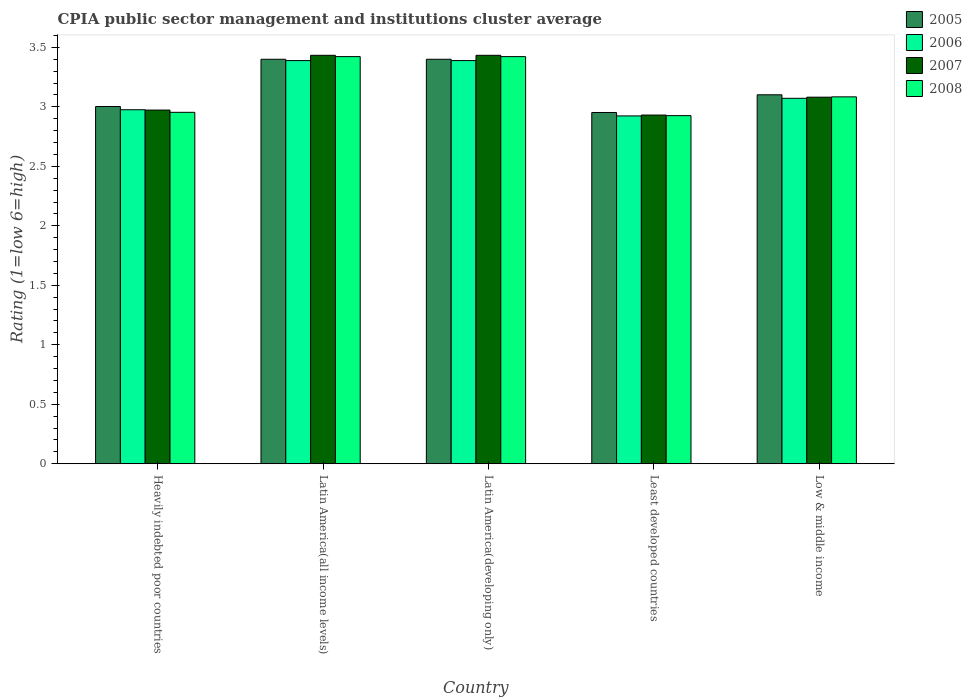How many different coloured bars are there?
Your answer should be compact. 4. How many bars are there on the 1st tick from the left?
Make the answer very short. 4. How many bars are there on the 2nd tick from the right?
Ensure brevity in your answer.  4. What is the label of the 1st group of bars from the left?
Provide a short and direct response. Heavily indebted poor countries. What is the CPIA rating in 2008 in Low & middle income?
Offer a terse response. 3.08. Across all countries, what is the maximum CPIA rating in 2007?
Offer a terse response. 3.43. Across all countries, what is the minimum CPIA rating in 2006?
Your response must be concise. 2.92. In which country was the CPIA rating in 2006 maximum?
Your answer should be very brief. Latin America(all income levels). In which country was the CPIA rating in 2008 minimum?
Make the answer very short. Least developed countries. What is the total CPIA rating in 2008 in the graph?
Keep it short and to the point. 15.81. What is the difference between the CPIA rating in 2006 in Heavily indebted poor countries and that in Least developed countries?
Offer a terse response. 0.05. What is the difference between the CPIA rating in 2005 in Heavily indebted poor countries and the CPIA rating in 2007 in Least developed countries?
Make the answer very short. 0.07. What is the average CPIA rating in 2007 per country?
Your answer should be very brief. 3.17. What is the difference between the CPIA rating of/in 2007 and CPIA rating of/in 2006 in Latin America(all income levels)?
Provide a succinct answer. 0.04. In how many countries, is the CPIA rating in 2005 greater than 0.2?
Offer a very short reply. 5. What is the ratio of the CPIA rating in 2008 in Latin America(all income levels) to that in Least developed countries?
Your answer should be compact. 1.17. Is the CPIA rating in 2005 in Latin America(developing only) less than that in Low & middle income?
Your answer should be very brief. No. Is the difference between the CPIA rating in 2007 in Latin America(developing only) and Low & middle income greater than the difference between the CPIA rating in 2006 in Latin America(developing only) and Low & middle income?
Keep it short and to the point. Yes. What is the difference between the highest and the second highest CPIA rating in 2005?
Give a very brief answer. -0.3. What is the difference between the highest and the lowest CPIA rating in 2007?
Ensure brevity in your answer.  0.5. In how many countries, is the CPIA rating in 2006 greater than the average CPIA rating in 2006 taken over all countries?
Your answer should be very brief. 2. How many bars are there?
Your response must be concise. 20. Where does the legend appear in the graph?
Offer a very short reply. Top right. How many legend labels are there?
Keep it short and to the point. 4. What is the title of the graph?
Your answer should be compact. CPIA public sector management and institutions cluster average. What is the label or title of the X-axis?
Ensure brevity in your answer.  Country. What is the Rating (1=low 6=high) in 2005 in Heavily indebted poor countries?
Make the answer very short. 3. What is the Rating (1=low 6=high) in 2006 in Heavily indebted poor countries?
Your answer should be very brief. 2.98. What is the Rating (1=low 6=high) in 2007 in Heavily indebted poor countries?
Your answer should be very brief. 2.97. What is the Rating (1=low 6=high) in 2008 in Heavily indebted poor countries?
Keep it short and to the point. 2.95. What is the Rating (1=low 6=high) in 2006 in Latin America(all income levels)?
Offer a terse response. 3.39. What is the Rating (1=low 6=high) in 2007 in Latin America(all income levels)?
Keep it short and to the point. 3.43. What is the Rating (1=low 6=high) of 2008 in Latin America(all income levels)?
Your answer should be very brief. 3.42. What is the Rating (1=low 6=high) in 2006 in Latin America(developing only)?
Provide a short and direct response. 3.39. What is the Rating (1=low 6=high) of 2007 in Latin America(developing only)?
Make the answer very short. 3.43. What is the Rating (1=low 6=high) in 2008 in Latin America(developing only)?
Give a very brief answer. 3.42. What is the Rating (1=low 6=high) of 2005 in Least developed countries?
Make the answer very short. 2.95. What is the Rating (1=low 6=high) in 2006 in Least developed countries?
Make the answer very short. 2.92. What is the Rating (1=low 6=high) in 2007 in Least developed countries?
Provide a short and direct response. 2.93. What is the Rating (1=low 6=high) in 2008 in Least developed countries?
Make the answer very short. 2.93. What is the Rating (1=low 6=high) of 2005 in Low & middle income?
Make the answer very short. 3.1. What is the Rating (1=low 6=high) in 2006 in Low & middle income?
Your response must be concise. 3.07. What is the Rating (1=low 6=high) of 2007 in Low & middle income?
Provide a short and direct response. 3.08. What is the Rating (1=low 6=high) in 2008 in Low & middle income?
Make the answer very short. 3.08. Across all countries, what is the maximum Rating (1=low 6=high) in 2005?
Your response must be concise. 3.4. Across all countries, what is the maximum Rating (1=low 6=high) in 2006?
Offer a terse response. 3.39. Across all countries, what is the maximum Rating (1=low 6=high) in 2007?
Make the answer very short. 3.43. Across all countries, what is the maximum Rating (1=low 6=high) in 2008?
Your answer should be very brief. 3.42. Across all countries, what is the minimum Rating (1=low 6=high) in 2005?
Your answer should be compact. 2.95. Across all countries, what is the minimum Rating (1=low 6=high) of 2006?
Ensure brevity in your answer.  2.92. Across all countries, what is the minimum Rating (1=low 6=high) in 2007?
Provide a succinct answer. 2.93. Across all countries, what is the minimum Rating (1=low 6=high) of 2008?
Provide a succinct answer. 2.93. What is the total Rating (1=low 6=high) of 2005 in the graph?
Offer a terse response. 15.86. What is the total Rating (1=low 6=high) in 2006 in the graph?
Ensure brevity in your answer.  15.75. What is the total Rating (1=low 6=high) of 2007 in the graph?
Ensure brevity in your answer.  15.85. What is the total Rating (1=low 6=high) in 2008 in the graph?
Make the answer very short. 15.81. What is the difference between the Rating (1=low 6=high) of 2005 in Heavily indebted poor countries and that in Latin America(all income levels)?
Make the answer very short. -0.4. What is the difference between the Rating (1=low 6=high) of 2006 in Heavily indebted poor countries and that in Latin America(all income levels)?
Provide a succinct answer. -0.41. What is the difference between the Rating (1=low 6=high) of 2007 in Heavily indebted poor countries and that in Latin America(all income levels)?
Your answer should be compact. -0.46. What is the difference between the Rating (1=low 6=high) of 2008 in Heavily indebted poor countries and that in Latin America(all income levels)?
Your answer should be very brief. -0.47. What is the difference between the Rating (1=low 6=high) of 2005 in Heavily indebted poor countries and that in Latin America(developing only)?
Your response must be concise. -0.4. What is the difference between the Rating (1=low 6=high) in 2006 in Heavily indebted poor countries and that in Latin America(developing only)?
Your answer should be very brief. -0.41. What is the difference between the Rating (1=low 6=high) of 2007 in Heavily indebted poor countries and that in Latin America(developing only)?
Offer a terse response. -0.46. What is the difference between the Rating (1=low 6=high) in 2008 in Heavily indebted poor countries and that in Latin America(developing only)?
Your answer should be very brief. -0.47. What is the difference between the Rating (1=low 6=high) of 2005 in Heavily indebted poor countries and that in Least developed countries?
Provide a short and direct response. 0.05. What is the difference between the Rating (1=low 6=high) of 2006 in Heavily indebted poor countries and that in Least developed countries?
Provide a short and direct response. 0.05. What is the difference between the Rating (1=low 6=high) of 2007 in Heavily indebted poor countries and that in Least developed countries?
Provide a succinct answer. 0.04. What is the difference between the Rating (1=low 6=high) in 2008 in Heavily indebted poor countries and that in Least developed countries?
Offer a very short reply. 0.03. What is the difference between the Rating (1=low 6=high) of 2005 in Heavily indebted poor countries and that in Low & middle income?
Ensure brevity in your answer.  -0.1. What is the difference between the Rating (1=low 6=high) in 2006 in Heavily indebted poor countries and that in Low & middle income?
Your answer should be very brief. -0.1. What is the difference between the Rating (1=low 6=high) of 2007 in Heavily indebted poor countries and that in Low & middle income?
Offer a terse response. -0.11. What is the difference between the Rating (1=low 6=high) in 2008 in Heavily indebted poor countries and that in Low & middle income?
Offer a terse response. -0.13. What is the difference between the Rating (1=low 6=high) of 2005 in Latin America(all income levels) and that in Latin America(developing only)?
Your answer should be very brief. 0. What is the difference between the Rating (1=low 6=high) in 2008 in Latin America(all income levels) and that in Latin America(developing only)?
Ensure brevity in your answer.  0. What is the difference between the Rating (1=low 6=high) of 2005 in Latin America(all income levels) and that in Least developed countries?
Your answer should be very brief. 0.45. What is the difference between the Rating (1=low 6=high) in 2006 in Latin America(all income levels) and that in Least developed countries?
Your answer should be very brief. 0.47. What is the difference between the Rating (1=low 6=high) in 2007 in Latin America(all income levels) and that in Least developed countries?
Your answer should be very brief. 0.5. What is the difference between the Rating (1=low 6=high) in 2008 in Latin America(all income levels) and that in Least developed countries?
Your answer should be compact. 0.5. What is the difference between the Rating (1=low 6=high) of 2005 in Latin America(all income levels) and that in Low & middle income?
Provide a short and direct response. 0.3. What is the difference between the Rating (1=low 6=high) of 2006 in Latin America(all income levels) and that in Low & middle income?
Offer a terse response. 0.32. What is the difference between the Rating (1=low 6=high) in 2007 in Latin America(all income levels) and that in Low & middle income?
Provide a short and direct response. 0.35. What is the difference between the Rating (1=low 6=high) in 2008 in Latin America(all income levels) and that in Low & middle income?
Provide a short and direct response. 0.34. What is the difference between the Rating (1=low 6=high) of 2005 in Latin America(developing only) and that in Least developed countries?
Provide a succinct answer. 0.45. What is the difference between the Rating (1=low 6=high) in 2006 in Latin America(developing only) and that in Least developed countries?
Make the answer very short. 0.47. What is the difference between the Rating (1=low 6=high) of 2007 in Latin America(developing only) and that in Least developed countries?
Make the answer very short. 0.5. What is the difference between the Rating (1=low 6=high) of 2008 in Latin America(developing only) and that in Least developed countries?
Ensure brevity in your answer.  0.5. What is the difference between the Rating (1=low 6=high) in 2005 in Latin America(developing only) and that in Low & middle income?
Give a very brief answer. 0.3. What is the difference between the Rating (1=low 6=high) in 2006 in Latin America(developing only) and that in Low & middle income?
Offer a terse response. 0.32. What is the difference between the Rating (1=low 6=high) of 2007 in Latin America(developing only) and that in Low & middle income?
Your answer should be very brief. 0.35. What is the difference between the Rating (1=low 6=high) in 2008 in Latin America(developing only) and that in Low & middle income?
Offer a terse response. 0.34. What is the difference between the Rating (1=low 6=high) in 2005 in Least developed countries and that in Low & middle income?
Your answer should be very brief. -0.15. What is the difference between the Rating (1=low 6=high) in 2006 in Least developed countries and that in Low & middle income?
Your answer should be compact. -0.15. What is the difference between the Rating (1=low 6=high) of 2007 in Least developed countries and that in Low & middle income?
Give a very brief answer. -0.15. What is the difference between the Rating (1=low 6=high) of 2008 in Least developed countries and that in Low & middle income?
Give a very brief answer. -0.16. What is the difference between the Rating (1=low 6=high) of 2005 in Heavily indebted poor countries and the Rating (1=low 6=high) of 2006 in Latin America(all income levels)?
Your response must be concise. -0.39. What is the difference between the Rating (1=low 6=high) in 2005 in Heavily indebted poor countries and the Rating (1=low 6=high) in 2007 in Latin America(all income levels)?
Make the answer very short. -0.43. What is the difference between the Rating (1=low 6=high) in 2005 in Heavily indebted poor countries and the Rating (1=low 6=high) in 2008 in Latin America(all income levels)?
Your response must be concise. -0.42. What is the difference between the Rating (1=low 6=high) in 2006 in Heavily indebted poor countries and the Rating (1=low 6=high) in 2007 in Latin America(all income levels)?
Your answer should be compact. -0.46. What is the difference between the Rating (1=low 6=high) of 2006 in Heavily indebted poor countries and the Rating (1=low 6=high) of 2008 in Latin America(all income levels)?
Provide a short and direct response. -0.45. What is the difference between the Rating (1=low 6=high) of 2007 in Heavily indebted poor countries and the Rating (1=low 6=high) of 2008 in Latin America(all income levels)?
Offer a very short reply. -0.45. What is the difference between the Rating (1=low 6=high) in 2005 in Heavily indebted poor countries and the Rating (1=low 6=high) in 2006 in Latin America(developing only)?
Offer a terse response. -0.39. What is the difference between the Rating (1=low 6=high) in 2005 in Heavily indebted poor countries and the Rating (1=low 6=high) in 2007 in Latin America(developing only)?
Your answer should be compact. -0.43. What is the difference between the Rating (1=low 6=high) of 2005 in Heavily indebted poor countries and the Rating (1=low 6=high) of 2008 in Latin America(developing only)?
Provide a short and direct response. -0.42. What is the difference between the Rating (1=low 6=high) of 2006 in Heavily indebted poor countries and the Rating (1=low 6=high) of 2007 in Latin America(developing only)?
Provide a succinct answer. -0.46. What is the difference between the Rating (1=low 6=high) in 2006 in Heavily indebted poor countries and the Rating (1=low 6=high) in 2008 in Latin America(developing only)?
Keep it short and to the point. -0.45. What is the difference between the Rating (1=low 6=high) of 2007 in Heavily indebted poor countries and the Rating (1=low 6=high) of 2008 in Latin America(developing only)?
Make the answer very short. -0.45. What is the difference between the Rating (1=low 6=high) in 2005 in Heavily indebted poor countries and the Rating (1=low 6=high) in 2006 in Least developed countries?
Keep it short and to the point. 0.08. What is the difference between the Rating (1=low 6=high) of 2005 in Heavily indebted poor countries and the Rating (1=low 6=high) of 2007 in Least developed countries?
Offer a very short reply. 0.07. What is the difference between the Rating (1=low 6=high) of 2005 in Heavily indebted poor countries and the Rating (1=low 6=high) of 2008 in Least developed countries?
Your answer should be very brief. 0.08. What is the difference between the Rating (1=low 6=high) in 2006 in Heavily indebted poor countries and the Rating (1=low 6=high) in 2007 in Least developed countries?
Give a very brief answer. 0.04. What is the difference between the Rating (1=low 6=high) in 2006 in Heavily indebted poor countries and the Rating (1=low 6=high) in 2008 in Least developed countries?
Offer a terse response. 0.05. What is the difference between the Rating (1=low 6=high) in 2007 in Heavily indebted poor countries and the Rating (1=low 6=high) in 2008 in Least developed countries?
Offer a very short reply. 0.05. What is the difference between the Rating (1=low 6=high) in 2005 in Heavily indebted poor countries and the Rating (1=low 6=high) in 2006 in Low & middle income?
Ensure brevity in your answer.  -0.07. What is the difference between the Rating (1=low 6=high) of 2005 in Heavily indebted poor countries and the Rating (1=low 6=high) of 2007 in Low & middle income?
Ensure brevity in your answer.  -0.08. What is the difference between the Rating (1=low 6=high) in 2005 in Heavily indebted poor countries and the Rating (1=low 6=high) in 2008 in Low & middle income?
Your answer should be compact. -0.08. What is the difference between the Rating (1=low 6=high) in 2006 in Heavily indebted poor countries and the Rating (1=low 6=high) in 2007 in Low & middle income?
Your answer should be very brief. -0.11. What is the difference between the Rating (1=low 6=high) of 2006 in Heavily indebted poor countries and the Rating (1=low 6=high) of 2008 in Low & middle income?
Provide a succinct answer. -0.11. What is the difference between the Rating (1=low 6=high) in 2007 in Heavily indebted poor countries and the Rating (1=low 6=high) in 2008 in Low & middle income?
Ensure brevity in your answer.  -0.11. What is the difference between the Rating (1=low 6=high) in 2005 in Latin America(all income levels) and the Rating (1=low 6=high) in 2006 in Latin America(developing only)?
Keep it short and to the point. 0.01. What is the difference between the Rating (1=low 6=high) in 2005 in Latin America(all income levels) and the Rating (1=low 6=high) in 2007 in Latin America(developing only)?
Provide a succinct answer. -0.03. What is the difference between the Rating (1=low 6=high) in 2005 in Latin America(all income levels) and the Rating (1=low 6=high) in 2008 in Latin America(developing only)?
Ensure brevity in your answer.  -0.02. What is the difference between the Rating (1=low 6=high) of 2006 in Latin America(all income levels) and the Rating (1=low 6=high) of 2007 in Latin America(developing only)?
Keep it short and to the point. -0.04. What is the difference between the Rating (1=low 6=high) of 2006 in Latin America(all income levels) and the Rating (1=low 6=high) of 2008 in Latin America(developing only)?
Make the answer very short. -0.03. What is the difference between the Rating (1=low 6=high) in 2007 in Latin America(all income levels) and the Rating (1=low 6=high) in 2008 in Latin America(developing only)?
Offer a terse response. 0.01. What is the difference between the Rating (1=low 6=high) in 2005 in Latin America(all income levels) and the Rating (1=low 6=high) in 2006 in Least developed countries?
Your answer should be very brief. 0.48. What is the difference between the Rating (1=low 6=high) in 2005 in Latin America(all income levels) and the Rating (1=low 6=high) in 2007 in Least developed countries?
Keep it short and to the point. 0.47. What is the difference between the Rating (1=low 6=high) in 2005 in Latin America(all income levels) and the Rating (1=low 6=high) in 2008 in Least developed countries?
Your response must be concise. 0.47. What is the difference between the Rating (1=low 6=high) in 2006 in Latin America(all income levels) and the Rating (1=low 6=high) in 2007 in Least developed countries?
Make the answer very short. 0.46. What is the difference between the Rating (1=low 6=high) in 2006 in Latin America(all income levels) and the Rating (1=low 6=high) in 2008 in Least developed countries?
Offer a very short reply. 0.46. What is the difference between the Rating (1=low 6=high) of 2007 in Latin America(all income levels) and the Rating (1=low 6=high) of 2008 in Least developed countries?
Your answer should be compact. 0.51. What is the difference between the Rating (1=low 6=high) in 2005 in Latin America(all income levels) and the Rating (1=low 6=high) in 2006 in Low & middle income?
Provide a succinct answer. 0.33. What is the difference between the Rating (1=low 6=high) of 2005 in Latin America(all income levels) and the Rating (1=low 6=high) of 2007 in Low & middle income?
Offer a terse response. 0.32. What is the difference between the Rating (1=low 6=high) in 2005 in Latin America(all income levels) and the Rating (1=low 6=high) in 2008 in Low & middle income?
Your response must be concise. 0.32. What is the difference between the Rating (1=low 6=high) in 2006 in Latin America(all income levels) and the Rating (1=low 6=high) in 2007 in Low & middle income?
Your answer should be very brief. 0.31. What is the difference between the Rating (1=low 6=high) of 2006 in Latin America(all income levels) and the Rating (1=low 6=high) of 2008 in Low & middle income?
Your answer should be compact. 0.3. What is the difference between the Rating (1=low 6=high) of 2007 in Latin America(all income levels) and the Rating (1=low 6=high) of 2008 in Low & middle income?
Your answer should be very brief. 0.35. What is the difference between the Rating (1=low 6=high) of 2005 in Latin America(developing only) and the Rating (1=low 6=high) of 2006 in Least developed countries?
Provide a short and direct response. 0.48. What is the difference between the Rating (1=low 6=high) of 2005 in Latin America(developing only) and the Rating (1=low 6=high) of 2007 in Least developed countries?
Keep it short and to the point. 0.47. What is the difference between the Rating (1=low 6=high) of 2005 in Latin America(developing only) and the Rating (1=low 6=high) of 2008 in Least developed countries?
Provide a succinct answer. 0.47. What is the difference between the Rating (1=low 6=high) in 2006 in Latin America(developing only) and the Rating (1=low 6=high) in 2007 in Least developed countries?
Provide a succinct answer. 0.46. What is the difference between the Rating (1=low 6=high) of 2006 in Latin America(developing only) and the Rating (1=low 6=high) of 2008 in Least developed countries?
Provide a succinct answer. 0.46. What is the difference between the Rating (1=low 6=high) of 2007 in Latin America(developing only) and the Rating (1=low 6=high) of 2008 in Least developed countries?
Provide a short and direct response. 0.51. What is the difference between the Rating (1=low 6=high) of 2005 in Latin America(developing only) and the Rating (1=low 6=high) of 2006 in Low & middle income?
Keep it short and to the point. 0.33. What is the difference between the Rating (1=low 6=high) in 2005 in Latin America(developing only) and the Rating (1=low 6=high) in 2007 in Low & middle income?
Make the answer very short. 0.32. What is the difference between the Rating (1=low 6=high) in 2005 in Latin America(developing only) and the Rating (1=low 6=high) in 2008 in Low & middle income?
Provide a succinct answer. 0.32. What is the difference between the Rating (1=low 6=high) in 2006 in Latin America(developing only) and the Rating (1=low 6=high) in 2007 in Low & middle income?
Keep it short and to the point. 0.31. What is the difference between the Rating (1=low 6=high) of 2006 in Latin America(developing only) and the Rating (1=low 6=high) of 2008 in Low & middle income?
Your answer should be compact. 0.3. What is the difference between the Rating (1=low 6=high) of 2007 in Latin America(developing only) and the Rating (1=low 6=high) of 2008 in Low & middle income?
Your answer should be compact. 0.35. What is the difference between the Rating (1=low 6=high) of 2005 in Least developed countries and the Rating (1=low 6=high) of 2006 in Low & middle income?
Ensure brevity in your answer.  -0.12. What is the difference between the Rating (1=low 6=high) of 2005 in Least developed countries and the Rating (1=low 6=high) of 2007 in Low & middle income?
Your answer should be compact. -0.13. What is the difference between the Rating (1=low 6=high) of 2005 in Least developed countries and the Rating (1=low 6=high) of 2008 in Low & middle income?
Keep it short and to the point. -0.13. What is the difference between the Rating (1=low 6=high) in 2006 in Least developed countries and the Rating (1=low 6=high) in 2007 in Low & middle income?
Provide a succinct answer. -0.16. What is the difference between the Rating (1=low 6=high) in 2006 in Least developed countries and the Rating (1=low 6=high) in 2008 in Low & middle income?
Provide a succinct answer. -0.16. What is the difference between the Rating (1=low 6=high) of 2007 in Least developed countries and the Rating (1=low 6=high) of 2008 in Low & middle income?
Offer a very short reply. -0.15. What is the average Rating (1=low 6=high) of 2005 per country?
Make the answer very short. 3.17. What is the average Rating (1=low 6=high) of 2006 per country?
Make the answer very short. 3.15. What is the average Rating (1=low 6=high) in 2007 per country?
Offer a very short reply. 3.17. What is the average Rating (1=low 6=high) in 2008 per country?
Offer a terse response. 3.16. What is the difference between the Rating (1=low 6=high) in 2005 and Rating (1=low 6=high) in 2006 in Heavily indebted poor countries?
Provide a succinct answer. 0.03. What is the difference between the Rating (1=low 6=high) in 2005 and Rating (1=low 6=high) in 2007 in Heavily indebted poor countries?
Offer a terse response. 0.03. What is the difference between the Rating (1=low 6=high) in 2005 and Rating (1=low 6=high) in 2008 in Heavily indebted poor countries?
Your answer should be very brief. 0.05. What is the difference between the Rating (1=low 6=high) in 2006 and Rating (1=low 6=high) in 2007 in Heavily indebted poor countries?
Provide a short and direct response. 0. What is the difference between the Rating (1=low 6=high) in 2006 and Rating (1=low 6=high) in 2008 in Heavily indebted poor countries?
Provide a succinct answer. 0.02. What is the difference between the Rating (1=low 6=high) in 2007 and Rating (1=low 6=high) in 2008 in Heavily indebted poor countries?
Keep it short and to the point. 0.02. What is the difference between the Rating (1=low 6=high) in 2005 and Rating (1=low 6=high) in 2006 in Latin America(all income levels)?
Keep it short and to the point. 0.01. What is the difference between the Rating (1=low 6=high) of 2005 and Rating (1=low 6=high) of 2007 in Latin America(all income levels)?
Provide a succinct answer. -0.03. What is the difference between the Rating (1=low 6=high) of 2005 and Rating (1=low 6=high) of 2008 in Latin America(all income levels)?
Give a very brief answer. -0.02. What is the difference between the Rating (1=low 6=high) of 2006 and Rating (1=low 6=high) of 2007 in Latin America(all income levels)?
Offer a terse response. -0.04. What is the difference between the Rating (1=low 6=high) of 2006 and Rating (1=low 6=high) of 2008 in Latin America(all income levels)?
Give a very brief answer. -0.03. What is the difference between the Rating (1=low 6=high) of 2007 and Rating (1=low 6=high) of 2008 in Latin America(all income levels)?
Your answer should be very brief. 0.01. What is the difference between the Rating (1=low 6=high) of 2005 and Rating (1=low 6=high) of 2006 in Latin America(developing only)?
Your response must be concise. 0.01. What is the difference between the Rating (1=low 6=high) in 2005 and Rating (1=low 6=high) in 2007 in Latin America(developing only)?
Your answer should be compact. -0.03. What is the difference between the Rating (1=low 6=high) in 2005 and Rating (1=low 6=high) in 2008 in Latin America(developing only)?
Your answer should be very brief. -0.02. What is the difference between the Rating (1=low 6=high) in 2006 and Rating (1=low 6=high) in 2007 in Latin America(developing only)?
Your answer should be very brief. -0.04. What is the difference between the Rating (1=low 6=high) of 2006 and Rating (1=low 6=high) of 2008 in Latin America(developing only)?
Provide a short and direct response. -0.03. What is the difference between the Rating (1=low 6=high) of 2007 and Rating (1=low 6=high) of 2008 in Latin America(developing only)?
Make the answer very short. 0.01. What is the difference between the Rating (1=low 6=high) of 2005 and Rating (1=low 6=high) of 2006 in Least developed countries?
Make the answer very short. 0.03. What is the difference between the Rating (1=low 6=high) in 2005 and Rating (1=low 6=high) in 2007 in Least developed countries?
Your answer should be very brief. 0.02. What is the difference between the Rating (1=low 6=high) of 2005 and Rating (1=low 6=high) of 2008 in Least developed countries?
Offer a very short reply. 0.03. What is the difference between the Rating (1=low 6=high) in 2006 and Rating (1=low 6=high) in 2007 in Least developed countries?
Provide a short and direct response. -0.01. What is the difference between the Rating (1=low 6=high) in 2006 and Rating (1=low 6=high) in 2008 in Least developed countries?
Give a very brief answer. -0. What is the difference between the Rating (1=low 6=high) in 2007 and Rating (1=low 6=high) in 2008 in Least developed countries?
Provide a succinct answer. 0. What is the difference between the Rating (1=low 6=high) in 2005 and Rating (1=low 6=high) in 2006 in Low & middle income?
Ensure brevity in your answer.  0.03. What is the difference between the Rating (1=low 6=high) of 2005 and Rating (1=low 6=high) of 2008 in Low & middle income?
Make the answer very short. 0.02. What is the difference between the Rating (1=low 6=high) of 2006 and Rating (1=low 6=high) of 2007 in Low & middle income?
Your answer should be compact. -0.01. What is the difference between the Rating (1=low 6=high) of 2006 and Rating (1=low 6=high) of 2008 in Low & middle income?
Ensure brevity in your answer.  -0.01. What is the difference between the Rating (1=low 6=high) of 2007 and Rating (1=low 6=high) of 2008 in Low & middle income?
Make the answer very short. -0. What is the ratio of the Rating (1=low 6=high) in 2005 in Heavily indebted poor countries to that in Latin America(all income levels)?
Provide a short and direct response. 0.88. What is the ratio of the Rating (1=low 6=high) of 2006 in Heavily indebted poor countries to that in Latin America(all income levels)?
Your response must be concise. 0.88. What is the ratio of the Rating (1=low 6=high) in 2007 in Heavily indebted poor countries to that in Latin America(all income levels)?
Your answer should be compact. 0.87. What is the ratio of the Rating (1=low 6=high) of 2008 in Heavily indebted poor countries to that in Latin America(all income levels)?
Ensure brevity in your answer.  0.86. What is the ratio of the Rating (1=low 6=high) of 2005 in Heavily indebted poor countries to that in Latin America(developing only)?
Your answer should be compact. 0.88. What is the ratio of the Rating (1=low 6=high) in 2006 in Heavily indebted poor countries to that in Latin America(developing only)?
Offer a very short reply. 0.88. What is the ratio of the Rating (1=low 6=high) in 2007 in Heavily indebted poor countries to that in Latin America(developing only)?
Your answer should be compact. 0.87. What is the ratio of the Rating (1=low 6=high) of 2008 in Heavily indebted poor countries to that in Latin America(developing only)?
Your answer should be compact. 0.86. What is the ratio of the Rating (1=low 6=high) of 2005 in Heavily indebted poor countries to that in Least developed countries?
Your answer should be very brief. 1.02. What is the ratio of the Rating (1=low 6=high) of 2006 in Heavily indebted poor countries to that in Least developed countries?
Offer a terse response. 1.02. What is the ratio of the Rating (1=low 6=high) in 2007 in Heavily indebted poor countries to that in Least developed countries?
Offer a terse response. 1.01. What is the ratio of the Rating (1=low 6=high) of 2008 in Heavily indebted poor countries to that in Least developed countries?
Your answer should be very brief. 1.01. What is the ratio of the Rating (1=low 6=high) in 2005 in Heavily indebted poor countries to that in Low & middle income?
Offer a very short reply. 0.97. What is the ratio of the Rating (1=low 6=high) in 2006 in Heavily indebted poor countries to that in Low & middle income?
Offer a terse response. 0.97. What is the ratio of the Rating (1=low 6=high) in 2007 in Heavily indebted poor countries to that in Low & middle income?
Ensure brevity in your answer.  0.96. What is the ratio of the Rating (1=low 6=high) in 2008 in Heavily indebted poor countries to that in Low & middle income?
Offer a terse response. 0.96. What is the ratio of the Rating (1=low 6=high) in 2005 in Latin America(all income levels) to that in Latin America(developing only)?
Provide a short and direct response. 1. What is the ratio of the Rating (1=low 6=high) in 2006 in Latin America(all income levels) to that in Latin America(developing only)?
Your answer should be compact. 1. What is the ratio of the Rating (1=low 6=high) of 2005 in Latin America(all income levels) to that in Least developed countries?
Offer a terse response. 1.15. What is the ratio of the Rating (1=low 6=high) of 2006 in Latin America(all income levels) to that in Least developed countries?
Offer a terse response. 1.16. What is the ratio of the Rating (1=low 6=high) in 2007 in Latin America(all income levels) to that in Least developed countries?
Your answer should be very brief. 1.17. What is the ratio of the Rating (1=low 6=high) in 2008 in Latin America(all income levels) to that in Least developed countries?
Make the answer very short. 1.17. What is the ratio of the Rating (1=low 6=high) of 2005 in Latin America(all income levels) to that in Low & middle income?
Your answer should be very brief. 1.1. What is the ratio of the Rating (1=low 6=high) of 2006 in Latin America(all income levels) to that in Low & middle income?
Offer a terse response. 1.1. What is the ratio of the Rating (1=low 6=high) of 2007 in Latin America(all income levels) to that in Low & middle income?
Offer a very short reply. 1.11. What is the ratio of the Rating (1=low 6=high) of 2008 in Latin America(all income levels) to that in Low & middle income?
Make the answer very short. 1.11. What is the ratio of the Rating (1=low 6=high) of 2005 in Latin America(developing only) to that in Least developed countries?
Offer a terse response. 1.15. What is the ratio of the Rating (1=low 6=high) in 2006 in Latin America(developing only) to that in Least developed countries?
Ensure brevity in your answer.  1.16. What is the ratio of the Rating (1=low 6=high) in 2007 in Latin America(developing only) to that in Least developed countries?
Offer a terse response. 1.17. What is the ratio of the Rating (1=low 6=high) of 2008 in Latin America(developing only) to that in Least developed countries?
Offer a terse response. 1.17. What is the ratio of the Rating (1=low 6=high) of 2005 in Latin America(developing only) to that in Low & middle income?
Offer a very short reply. 1.1. What is the ratio of the Rating (1=low 6=high) in 2006 in Latin America(developing only) to that in Low & middle income?
Keep it short and to the point. 1.1. What is the ratio of the Rating (1=low 6=high) of 2007 in Latin America(developing only) to that in Low & middle income?
Your answer should be compact. 1.11. What is the ratio of the Rating (1=low 6=high) in 2008 in Latin America(developing only) to that in Low & middle income?
Make the answer very short. 1.11. What is the ratio of the Rating (1=low 6=high) in 2005 in Least developed countries to that in Low & middle income?
Your response must be concise. 0.95. What is the ratio of the Rating (1=low 6=high) in 2006 in Least developed countries to that in Low & middle income?
Offer a very short reply. 0.95. What is the ratio of the Rating (1=low 6=high) in 2007 in Least developed countries to that in Low & middle income?
Your answer should be compact. 0.95. What is the ratio of the Rating (1=low 6=high) in 2008 in Least developed countries to that in Low & middle income?
Keep it short and to the point. 0.95. What is the difference between the highest and the second highest Rating (1=low 6=high) in 2005?
Offer a very short reply. 0. What is the difference between the highest and the second highest Rating (1=low 6=high) in 2008?
Your answer should be very brief. 0. What is the difference between the highest and the lowest Rating (1=low 6=high) of 2005?
Ensure brevity in your answer.  0.45. What is the difference between the highest and the lowest Rating (1=low 6=high) of 2006?
Your response must be concise. 0.47. What is the difference between the highest and the lowest Rating (1=low 6=high) of 2007?
Offer a very short reply. 0.5. What is the difference between the highest and the lowest Rating (1=low 6=high) in 2008?
Provide a succinct answer. 0.5. 